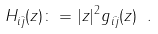Convert formula to latex. <formula><loc_0><loc_0><loc_500><loc_500>H _ { i \bar { j } } ( z ) \colon = | z | ^ { 2 } g _ { i \bar { j } } ( z ) \ .</formula> 